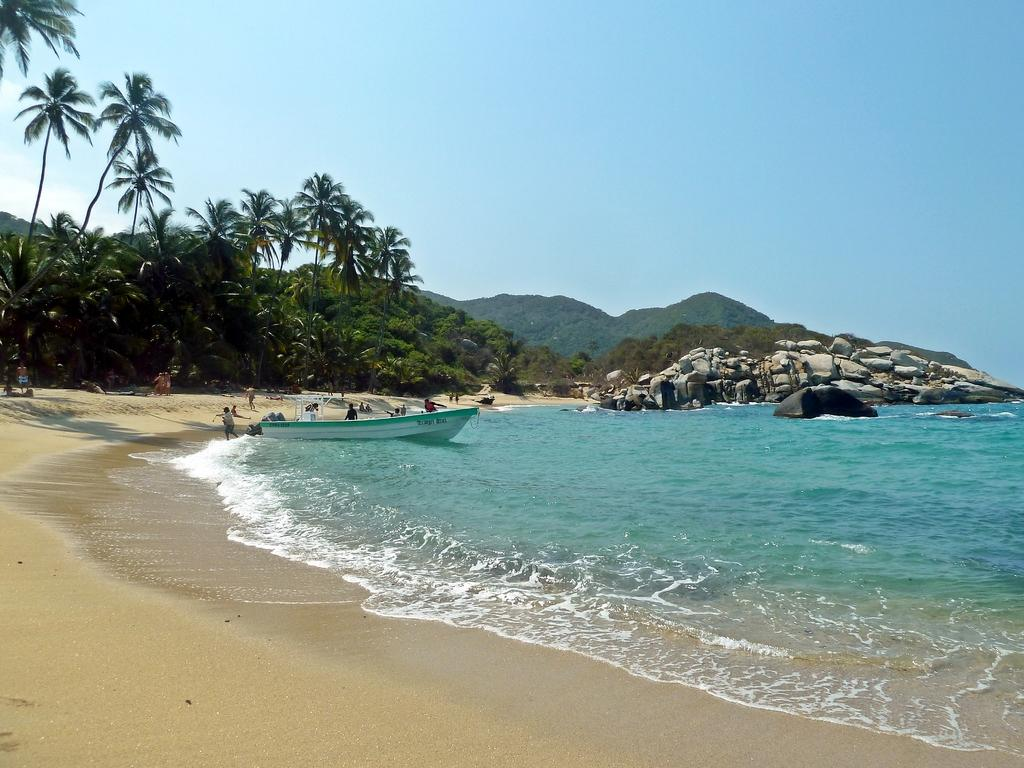What is the main subject in the center of the image? There is a boat in the center of the image. What can be seen near the boat? There are people standing near the boat. What is visible in the background of the image? The sky, trees, hills, stones, and water are visible in the background of the image. Can you see a zebra in the image? No, there is no zebra present in the image. What type of tools might a carpenter use in the image? There is no carpenter or carpentry tools present in the image. 